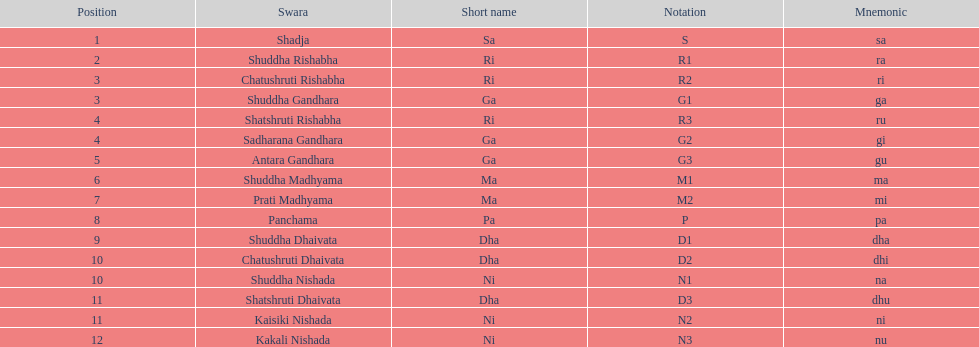Excluding m1, how many representations have "1" in them? 4. 